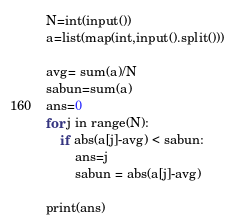<code> <loc_0><loc_0><loc_500><loc_500><_Python_>N=int(input())
a=list(map(int,input().split()))

avg= sum(a)/N
sabun=sum(a)
ans=0
for j in range(N):
    if abs(a[j]-avg) < sabun:
        ans=j
        sabun = abs(a[j]-avg)

print(ans)
</code> 